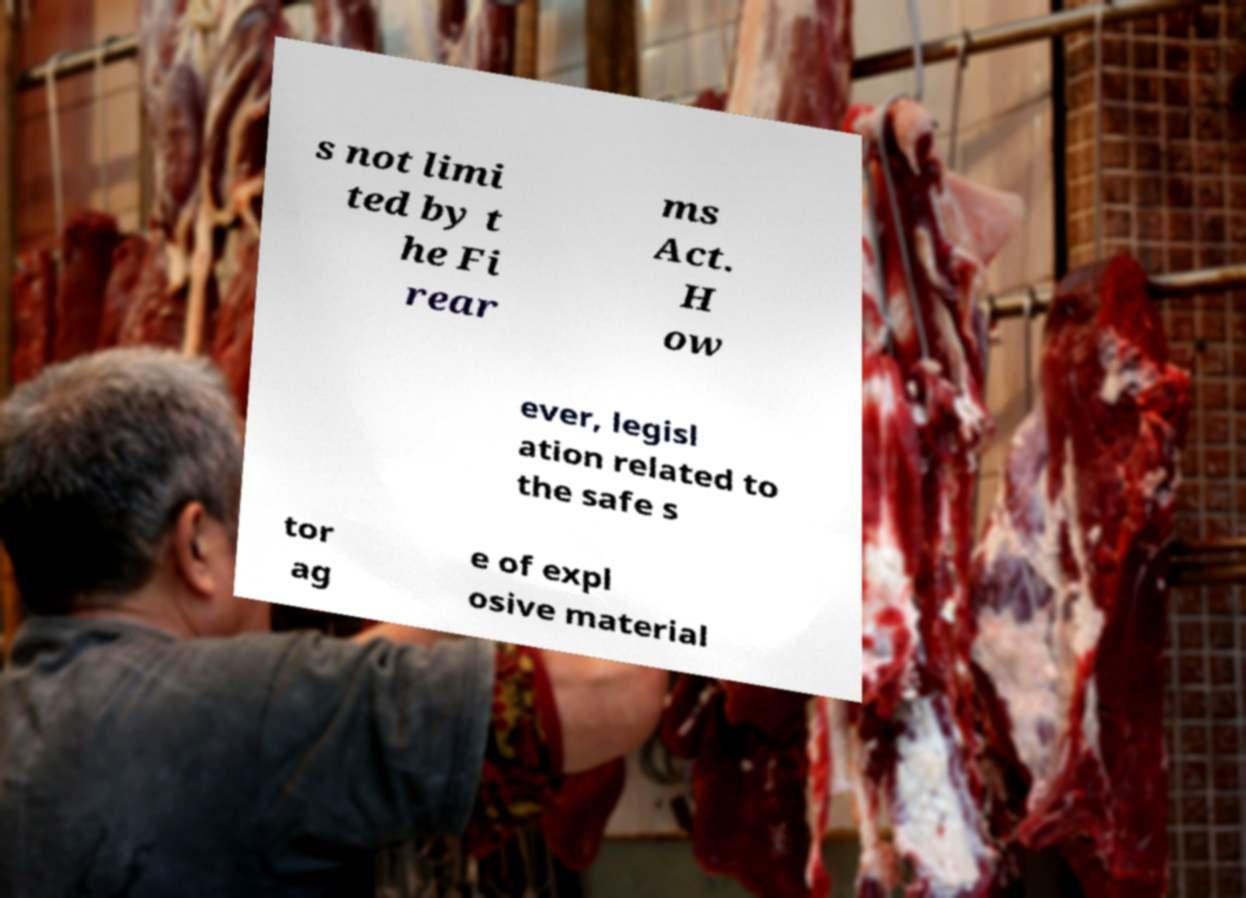Please read and relay the text visible in this image. What does it say? s not limi ted by t he Fi rear ms Act. H ow ever, legisl ation related to the safe s tor ag e of expl osive material 